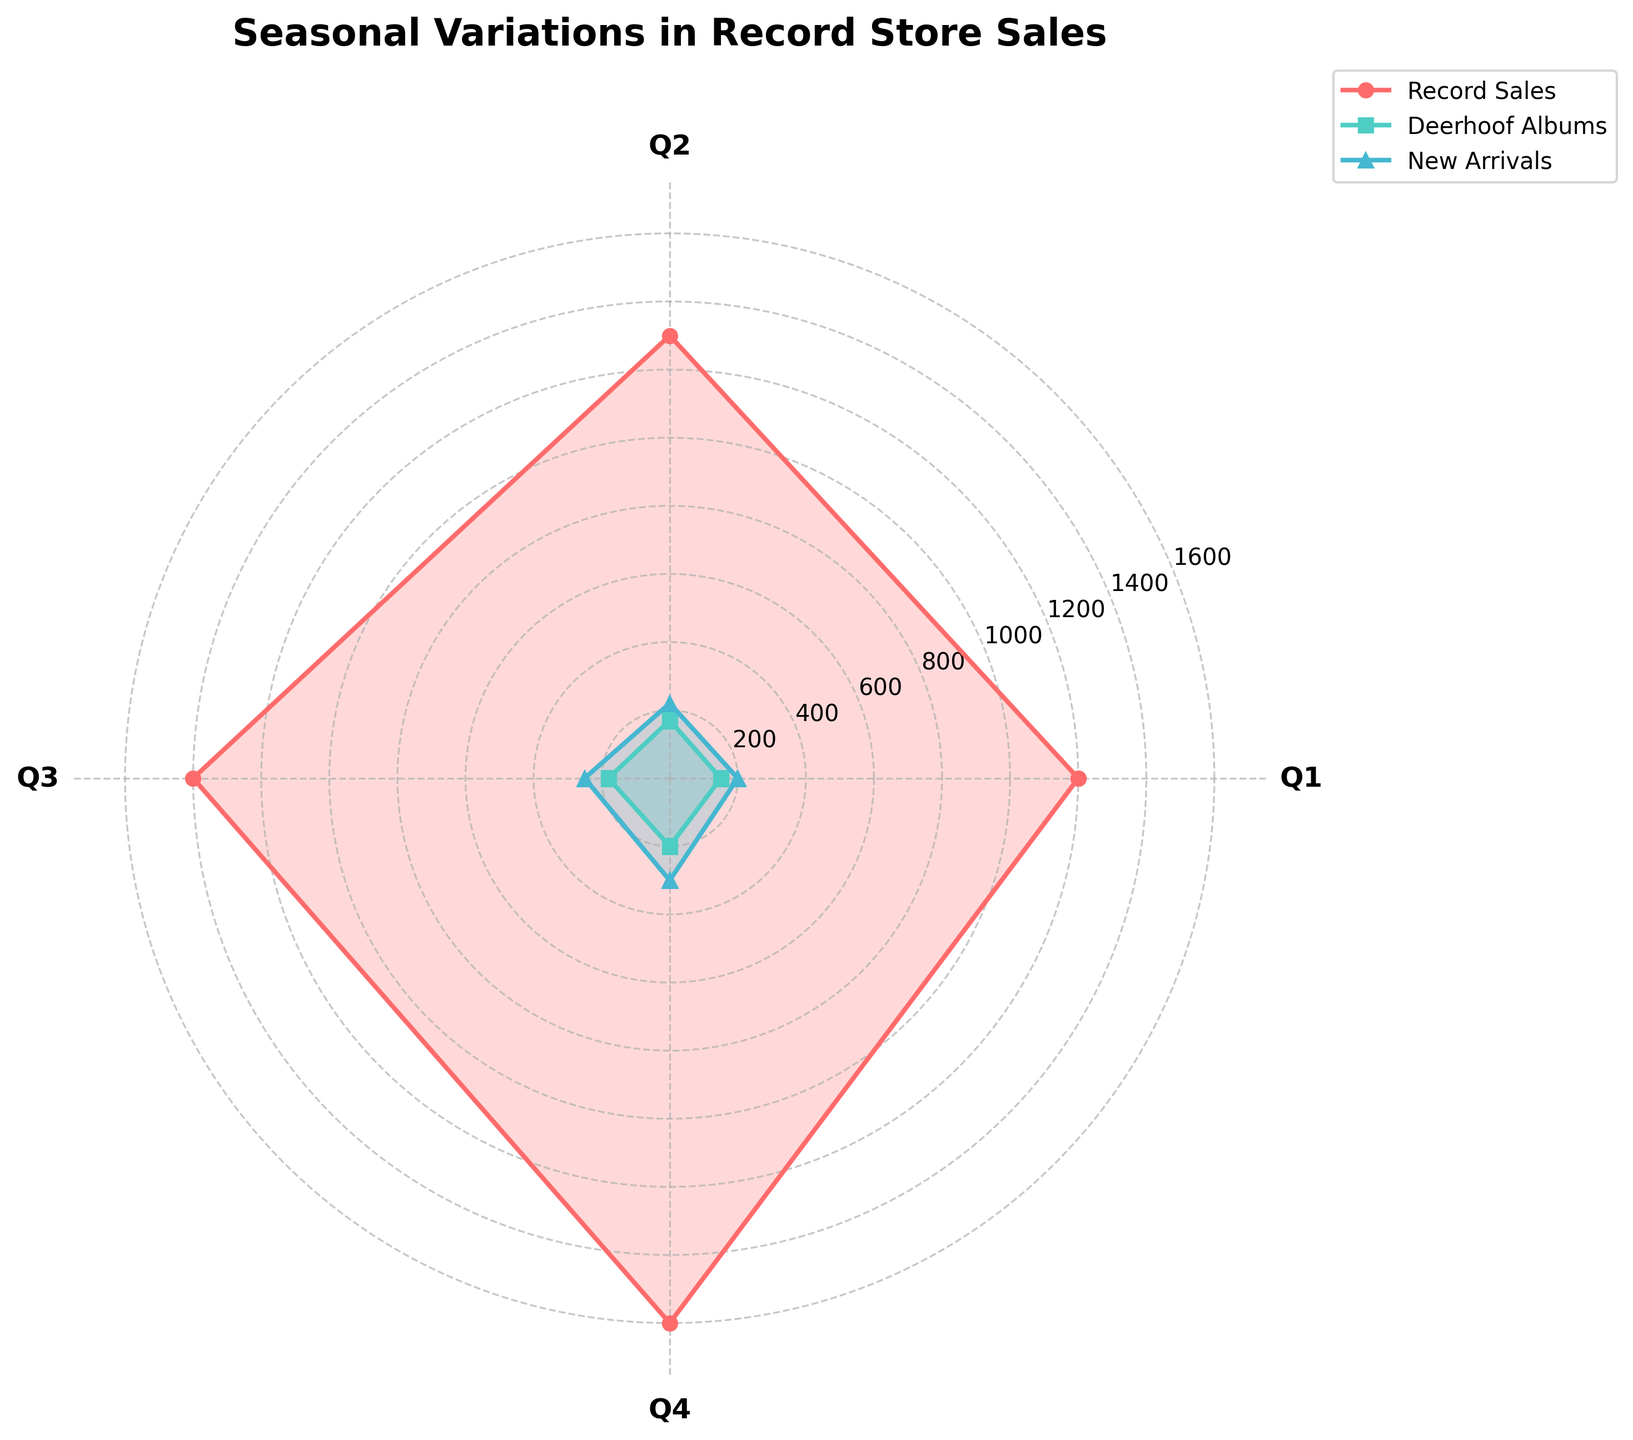What's the title of the chart? The title is usually displayed at the top of the chart. In this case, the title is clearly shown as "Seasonal Variations in Record Store Sales".
Answer: Seasonal Variations in Record Store Sales Which quarter has the highest total record sales? To find the quarter with the highest total record sales, we look at the largest values along the "Record Sales" line on the chart. The highest value appears for Q4.
Answer: Q4 How do Deerhoof album sales in Q2 compare to Q1? We look at the values for Deerhoof albums for Q1 and Q2 along the "Deerhoof Albums" line. Q1 has 150 units, and Q2 has 170 units, so Q2 has higher sales.
Answer: Q2 has higher sales Which category has the steepest increase between any two consecutive quarters? To identify the steepest increase, we look at the vertical distances between points of each line across quarters. The steepest increase is seen in "New Arrivals" from Q3 to Q4.
Answer: New Arrivals What is the difference in record sales between Q4 and Q1? Look at the record sales units for Q4 and Q1, which are 1,600 and 1,200 respectively. Subtract Q1 sales from Q4 sales. 1600 - 1200 = 400.
Answer: 400 How many quarters show Deerhoof album sales reaching or exceeding 200 units? The line for Deerhoof Albums shows that only in Q4 do album sales reach 200 units.
Answer: 1 What's the average new arrivals sales across all quarters? Sum the new arrivals units for each quarter (200 + 220 + 250 + 300) and divide by the number of quarters (4). (200 + 220 + 250 + 300) / 4 = 242.5
Answer: 242.5 Which quarter shows the closest values between new arrivals and record sales? Compare the values for new arrivals and record sales for all quarters and find the smallest difference. Q4 has the smallest difference: 1600 (Record Sales) - 300 (New Arrivals) = 1300.
Answer: Q4 